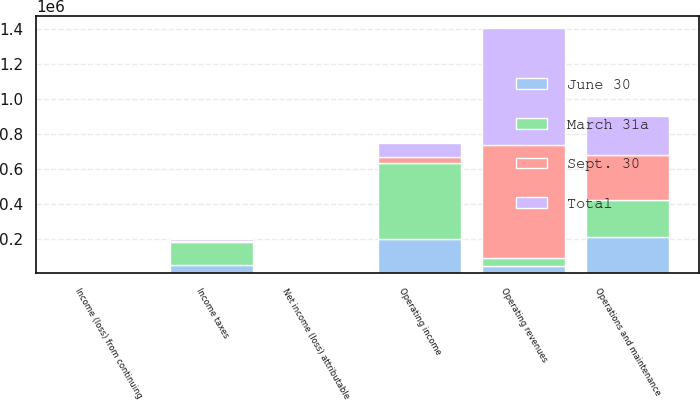Convert chart to OTSL. <chart><loc_0><loc_0><loc_500><loc_500><stacked_bar_chart><ecel><fcel>Operating revenues<fcel>Operations and maintenance<fcel>Operating income<fcel>Income taxes<fcel>Income (loss) from continuing<fcel>Net income (loss) attributable<nl><fcel>Sept. 30<fcel>648847<fcel>255029<fcel>35784<fcel>6005<fcel>0.15<fcel>0.14<nl><fcel>June 30<fcel>43301<fcel>210590<fcel>196992<fcel>50818<fcel>0.79<fcel>0.8<nl><fcel>March 31a<fcel>43301<fcel>210035<fcel>435017<fcel>131416<fcel>2.25<fcel>2.34<nl><fcel>Total<fcel>667892<fcel>228632<fcel>78715<fcel>7375<fcel>0.11<fcel>0.12<nl></chart> 